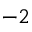Convert formula to latex. <formula><loc_0><loc_0><loc_500><loc_500>^ { - 2 }</formula> 